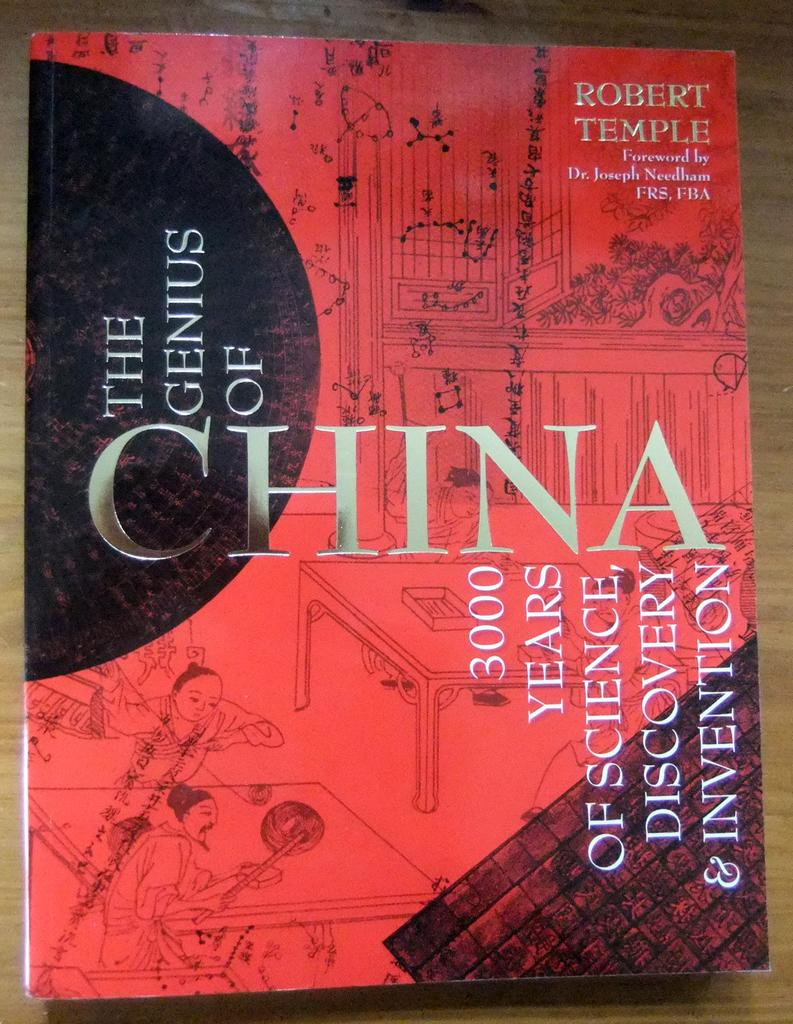<image>
Offer a succinct explanation of the picture presented. The genius of China book sits on a wooden table alone. 